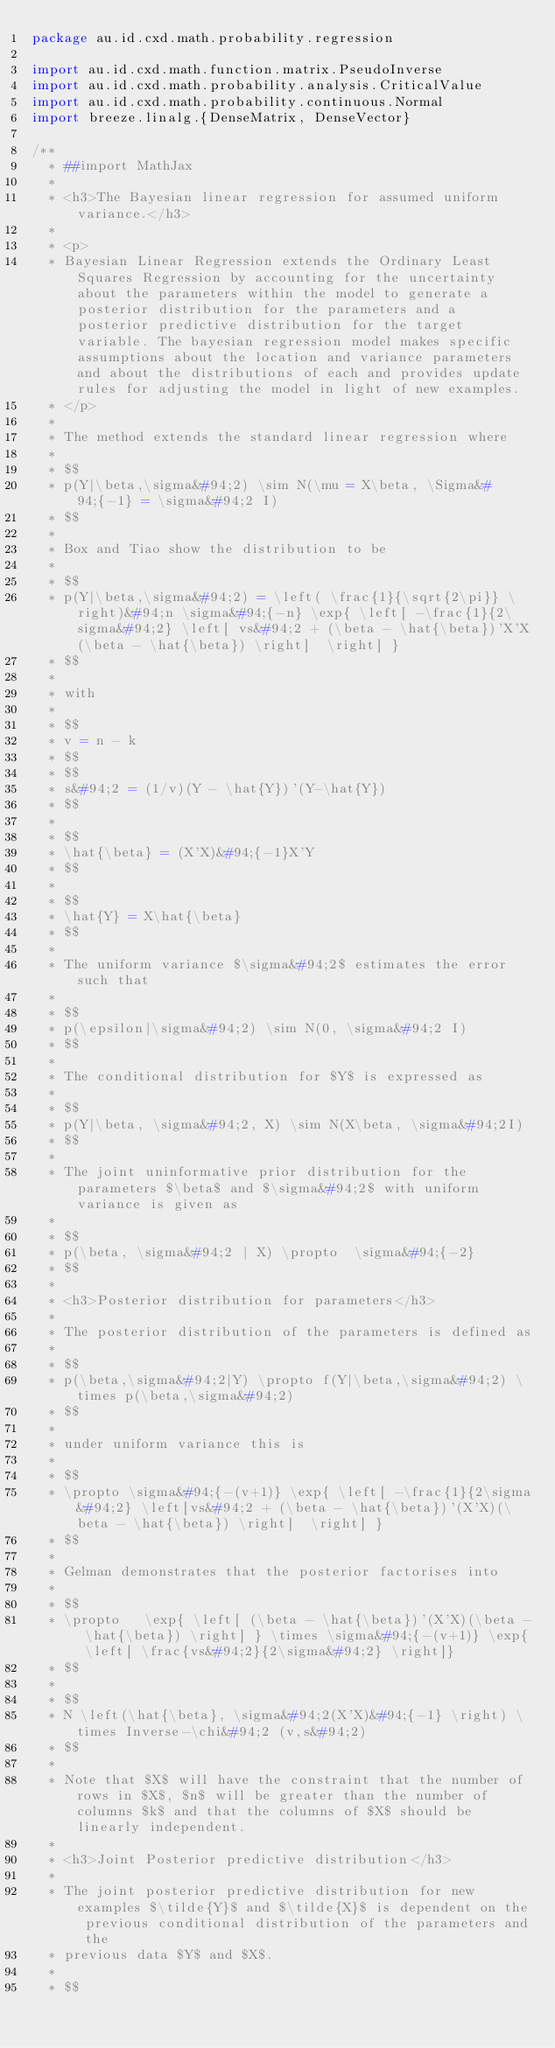Convert code to text. <code><loc_0><loc_0><loc_500><loc_500><_Scala_>package au.id.cxd.math.probability.regression

import au.id.cxd.math.function.matrix.PseudoInverse
import au.id.cxd.math.probability.analysis.CriticalValue
import au.id.cxd.math.probability.continuous.Normal
import breeze.linalg.{DenseMatrix, DenseVector}

/**
  * ##import MathJax
  *
  * <h3>The Bayesian linear regression for assumed uniform variance.</h3>
  *
  * <p>
  * Bayesian Linear Regression extends the Ordinary Least Squares Regression by accounting for the uncertainty about the parameters within the model to generate a posterior distribution for the parameters and a posterior predictive distribution for the target variable. The bayesian regression model makes specific assumptions about the location and variance parameters and about the distributions of each and provides update rules for adjusting the model in light of new examples.
  * </p>
  *
  * The method extends the standard linear regression where
  *
  * $$
  * p(Y|\beta,\sigma&#94;2) \sim N(\mu = X\beta, \Sigma&#94;{-1} = \sigma&#94;2 I)
  * $$
  *
  * Box and Tiao show the distribution to be
  *
  * $$
  * p(Y|\beta,\sigma&#94;2) = \left( \frac{1}{\sqrt{2\pi}} \right)&#94;n \sigma&#94;{-n} \exp{ \left[ -\frac{1}{2\sigma&#94;2} \left[ vs&#94;2 + (\beta - \hat{\beta})'X'X(\beta - \hat{\beta}) \right]  \right] }
  * $$
  *
  * with
  *
  * $$
  * v = n - k
  * $$
  * $$
  * s&#94;2 = (1/v)(Y - \hat{Y})'(Y-\hat{Y})
  * $$
  *
  * $$
  * \hat{\beta} = (X'X)&#94;{-1}X'Y
  * $$
  *
  * $$
  * \hat{Y} = X\hat{\beta}
  * $$
  *
  * The uniform variance $\sigma&#94;2$ estimates the error such that
  *
  * $$
  * p(\epsilon|\sigma&#94;2) \sim N(0, \sigma&#94;2 I)
  * $$
  *
  * The conditional distribution for $Y$ is expressed as
  *
  * $$
  * p(Y|\beta, \sigma&#94;2, X) \sim N(X\beta, \sigma&#94;2I)
  * $$
  *
  * The joint uninformative prior distribution for the parameters $\beta$ and $\sigma&#94;2$ with uniform variance is given as
  *
  * $$
  * p(\beta, \sigma&#94;2 | X) \propto  \sigma&#94;{-2}
  * $$
  *
  * <h3>Posterior distribution for parameters</h3>
  *
  * The posterior distribution of the parameters is defined as
  *
  * $$
  * p(\beta,\sigma&#94;2|Y) \propto f(Y|\beta,\sigma&#94;2) \times p(\beta,\sigma&#94;2)
  * $$
  *
  * under uniform variance this is
  *
  * $$
  * \propto \sigma&#94;{-(v+1)} \exp{ \left[ -\frac{1}{2\sigma&#94;2} \left[vs&#94;2 + (\beta - \hat{\beta})'(X'X)(\beta - \hat{\beta}) \right]  \right] }
  * $$
  *
  * Gelman demonstrates that the posterior factorises into
  *
  * $$
  * \propto   \exp{ \left[ (\beta - \hat{\beta})'(X'X)(\beta - \hat{\beta}) \right] } \times \sigma&#94;{-(v+1)} \exp{ \left[ \frac{vs&#94;2}{2\sigma&#94;2} \right]}
  * $$
  *
  * $$
  * N \left(\hat{\beta}, \sigma&#94;2(X'X)&#94;{-1} \right) \times Inverse-\chi&#94;2 (v,s&#94;2)
  * $$
  *
  * Note that $X$ will have the constraint that the number of rows in $X$, $n$ will be greater than the number of columns $k$ and that the columns of $X$ should be linearly independent.
  *
  * <h3>Joint Posterior predictive distribution</h3>
  *
  * The joint posterior predictive distribution for new examples $\tilde{Y}$ and $\tilde{X}$ is dependent on the previous conditional distribution of the parameters and the
  * previous data $Y$ and $X$.
  *
  * $$</code> 